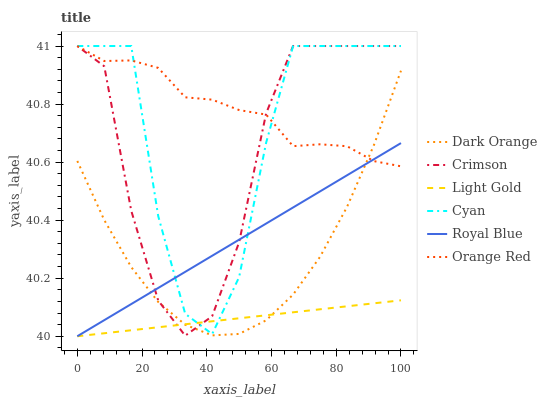Does Light Gold have the minimum area under the curve?
Answer yes or no. Yes. Does Orange Red have the maximum area under the curve?
Answer yes or no. Yes. Does Royal Blue have the minimum area under the curve?
Answer yes or no. No. Does Royal Blue have the maximum area under the curve?
Answer yes or no. No. Is Royal Blue the smoothest?
Answer yes or no. Yes. Is Cyan the roughest?
Answer yes or no. Yes. Is Crimson the smoothest?
Answer yes or no. No. Is Crimson the roughest?
Answer yes or no. No. Does Crimson have the lowest value?
Answer yes or no. No. Does Orange Red have the highest value?
Answer yes or no. Yes. Does Royal Blue have the highest value?
Answer yes or no. No. Is Dark Orange less than Cyan?
Answer yes or no. Yes. Is Cyan greater than Dark Orange?
Answer yes or no. Yes. Does Royal Blue intersect Orange Red?
Answer yes or no. Yes. Is Royal Blue less than Orange Red?
Answer yes or no. No. Is Royal Blue greater than Orange Red?
Answer yes or no. No. Does Dark Orange intersect Cyan?
Answer yes or no. No. 